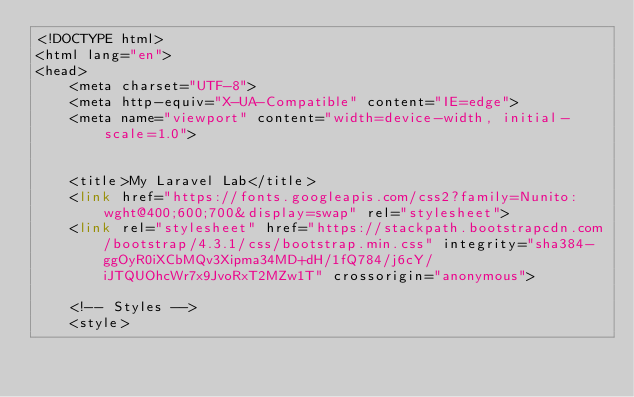<code> <loc_0><loc_0><loc_500><loc_500><_PHP_><!DOCTYPE html>
<html lang="en">
<head>
    <meta charset="UTF-8">
    <meta http-equiv="X-UA-Compatible" content="IE=edge">
    <meta name="viewport" content="width=device-width, initial-scale=1.0">

    
    <title>My Laravel Lab</title>
    <link href="https://fonts.googleapis.com/css2?family=Nunito:wght@400;600;700&display=swap" rel="stylesheet">
    <link rel="stylesheet" href="https://stackpath.bootstrapcdn.com/bootstrap/4.3.1/css/bootstrap.min.css" integrity="sha384-ggOyR0iXCbMQv3Xipma34MD+dH/1fQ784/j6cY/iJTQUOhcWr7x9JvoRxT2MZw1T" crossorigin="anonymous">

    <!-- Styles -->
    <style></code> 